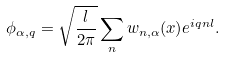<formula> <loc_0><loc_0><loc_500><loc_500>\phi _ { \alpha , q } = \sqrt { \frac { l } { 2 \pi } } \sum _ { n } w _ { n , \alpha } ( x ) e ^ { i q n l } .</formula> 